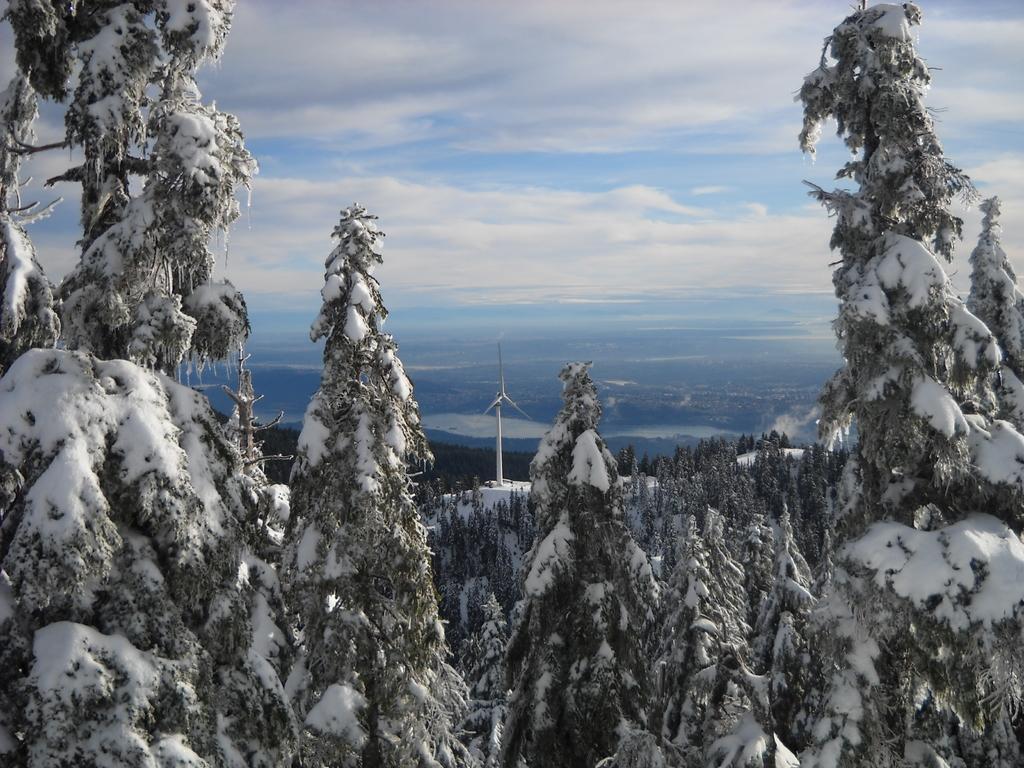Describe this image in one or two sentences. This picture shows few trees and we see snow and a wind mill and a blue cloudy sky. 